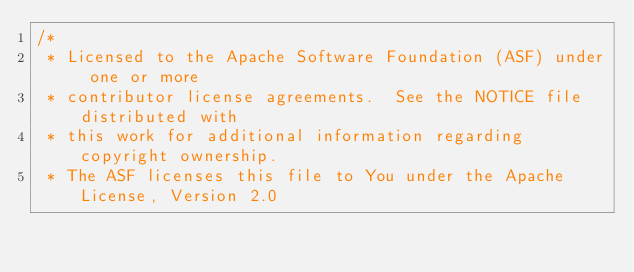Convert code to text. <code><loc_0><loc_0><loc_500><loc_500><_Scala_>/*
 * Licensed to the Apache Software Foundation (ASF) under one or more
 * contributor license agreements.  See the NOTICE file distributed with
 * this work for additional information regarding copyright ownership.
 * The ASF licenses this file to You under the Apache License, Version 2.0</code> 